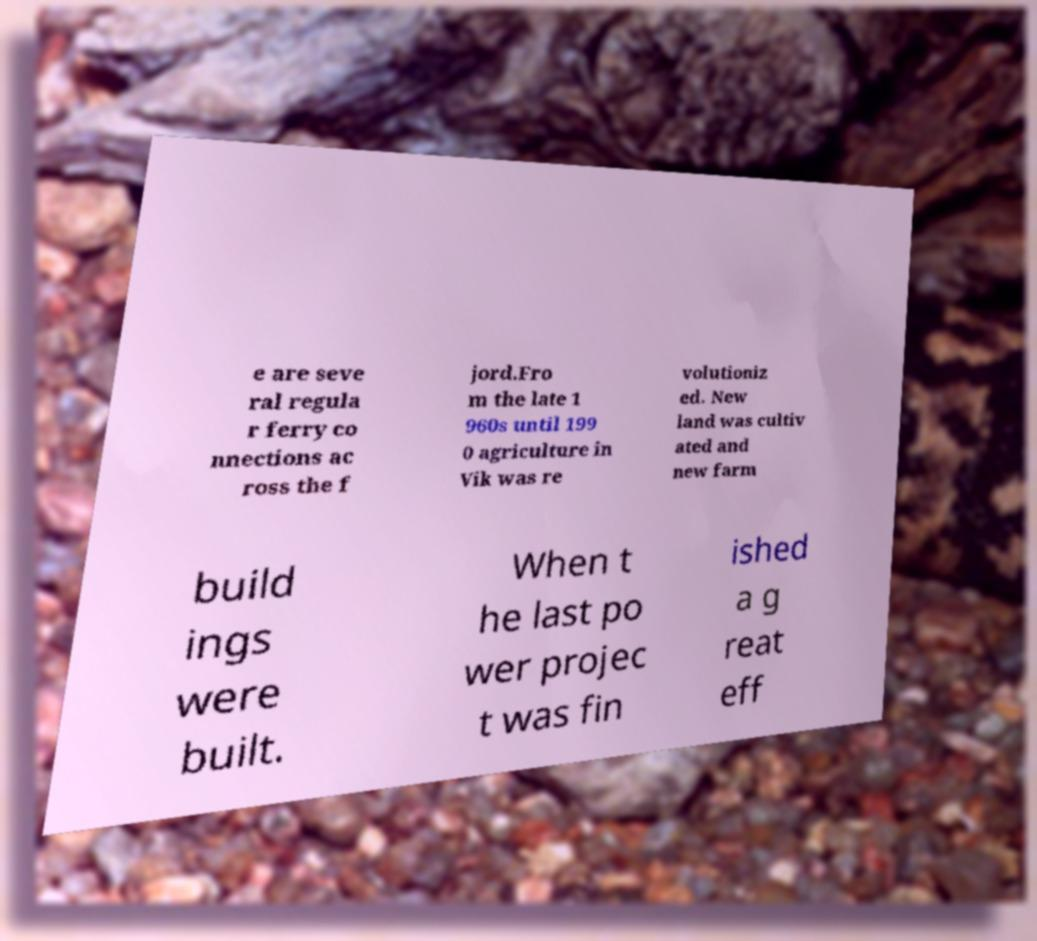Could you assist in decoding the text presented in this image and type it out clearly? e are seve ral regula r ferry co nnections ac ross the f jord.Fro m the late 1 960s until 199 0 agriculture in Vik was re volutioniz ed. New land was cultiv ated and new farm build ings were built. When t he last po wer projec t was fin ished a g reat eff 